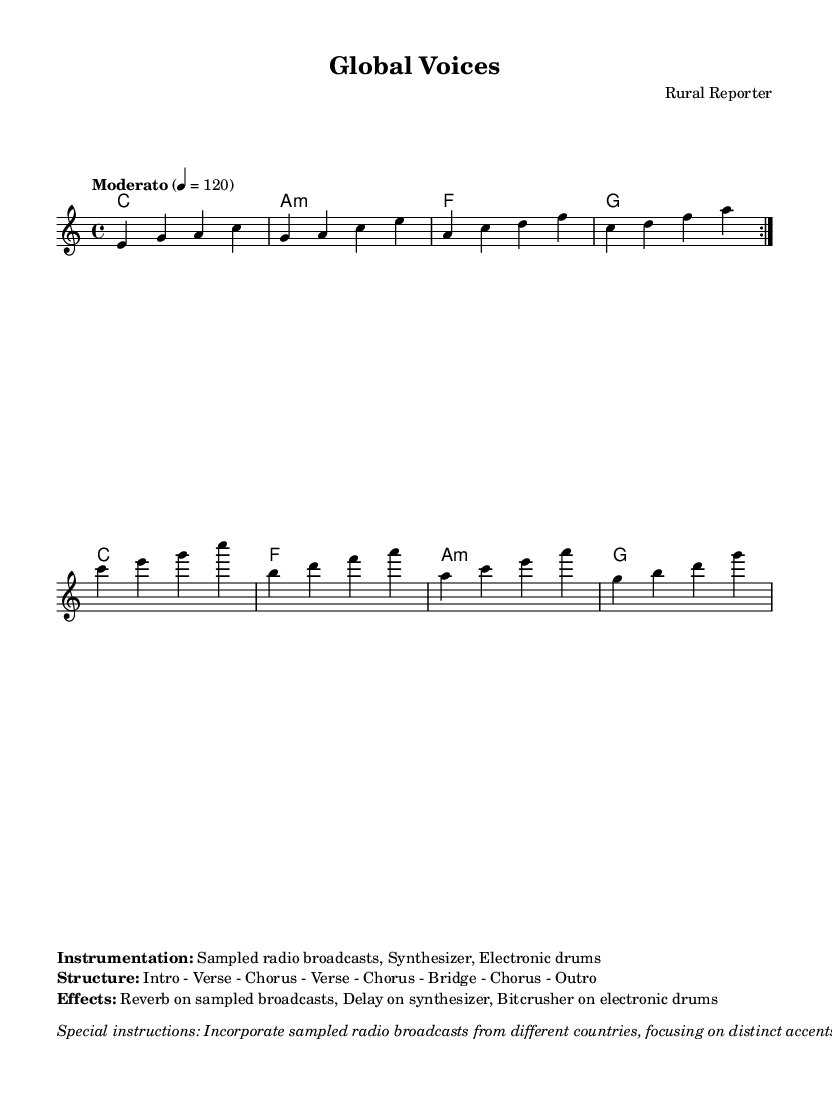What is the key signature of this music? The key signature is indicated at the beginning of the score and is noted as C major, which has no sharps or flats.
Answer: C major What is the time signature of this piece? The time signature can be found in the global section of the score, where it is noted as 4/4, meaning there are four beats per measure.
Answer: 4/4 What is the tempo of the composition? The tempo indication appears at the start of the score, listed as "Moderato" and corresponding to a metronome marking of 120 beats per minute.
Answer: Moderato 4 = 120 How many sections are in the structure of the piece? The structure of the composition is laid out in the markup section, which lists the parts as "Intro - Verse - Chorus - Verse - Chorus - Bridge - Chorus - Outro," adding up to seven distinct sections.
Answer: 7 What type of instrumentations are included? Instrumentations are detailed in the markup section, where it states that the piece includes "Sampled radio broadcasts, Synthesizer, Electronic drums."
Answer: Sampled radio broadcasts, Synthesizer, Electronic drums What is the main effect used on the sampled broadcasts? The effects for the piece are specified in the markup section, stating that "Reverb on sampled broadcasts" is the primary effect applied to the sampled audio.
Answer: Reverb How is the melody structured in relation to the radio samples? The special instructions in the markup indicate that "Incorporate sampled radio broadcasts from different countries, focusing on distinct accents and languages," suggesting that the melody is layered and developed around these elements.
Answer: Layered and developed around sampled broadcasts 